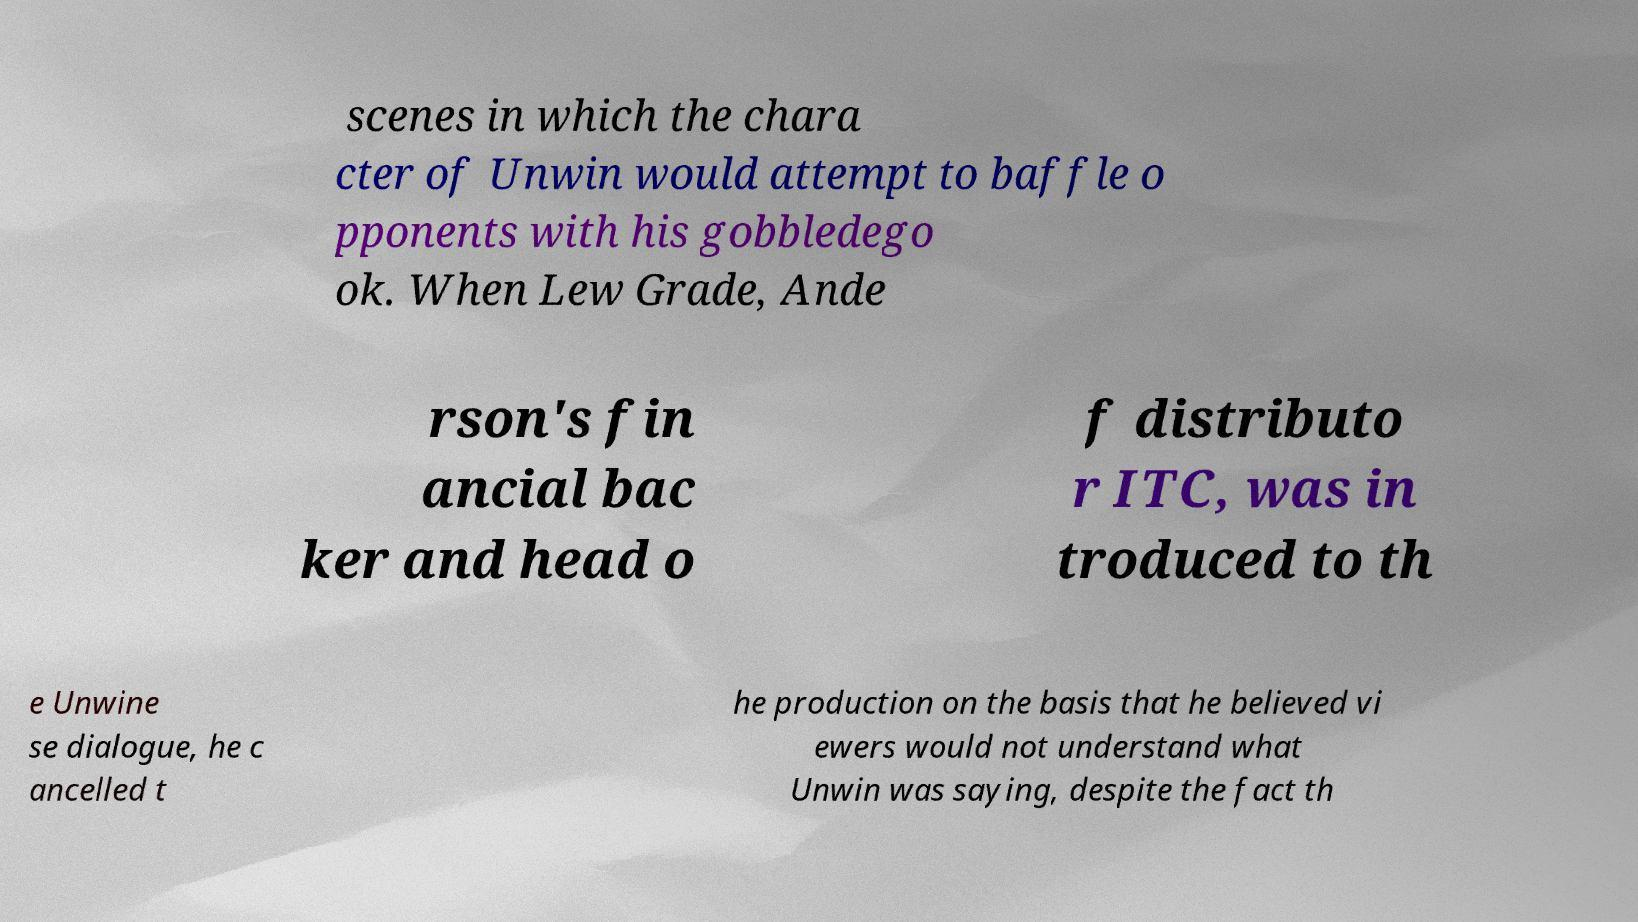I need the written content from this picture converted into text. Can you do that? scenes in which the chara cter of Unwin would attempt to baffle o pponents with his gobbledego ok. When Lew Grade, Ande rson's fin ancial bac ker and head o f distributo r ITC, was in troduced to th e Unwine se dialogue, he c ancelled t he production on the basis that he believed vi ewers would not understand what Unwin was saying, despite the fact th 